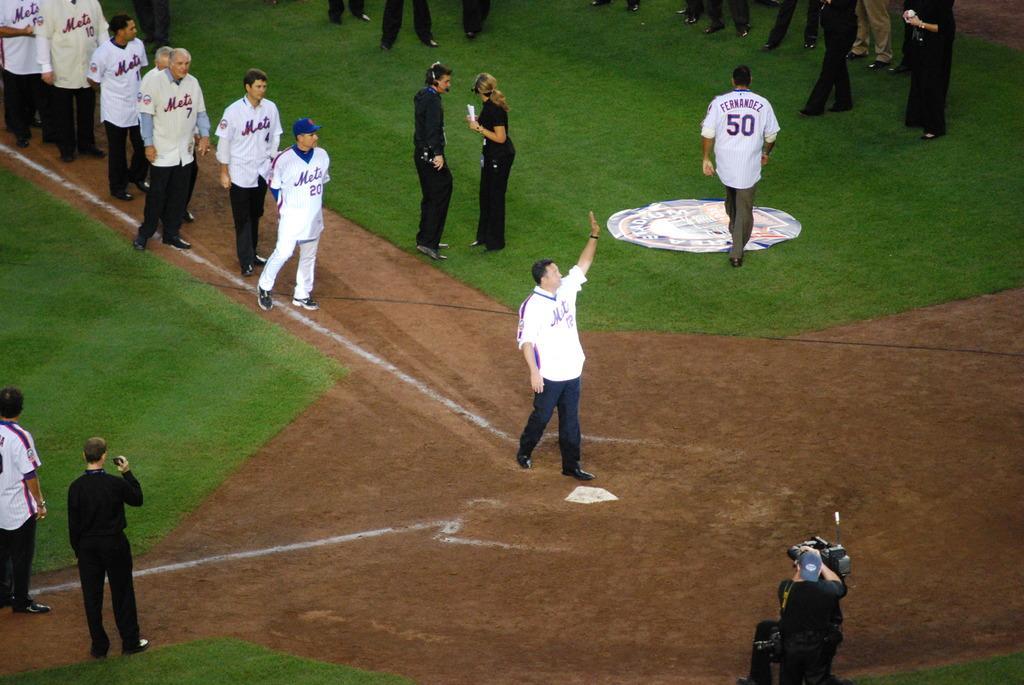Could you give a brief overview of what you see in this image? In this image we can see a few persons. Here we can see a man on the bottom right side and he is capturing an image with a camera. Here we can see two people having the conversation. Here we can see the grass on the ground. Here we can see the legs of the persons at the top. 